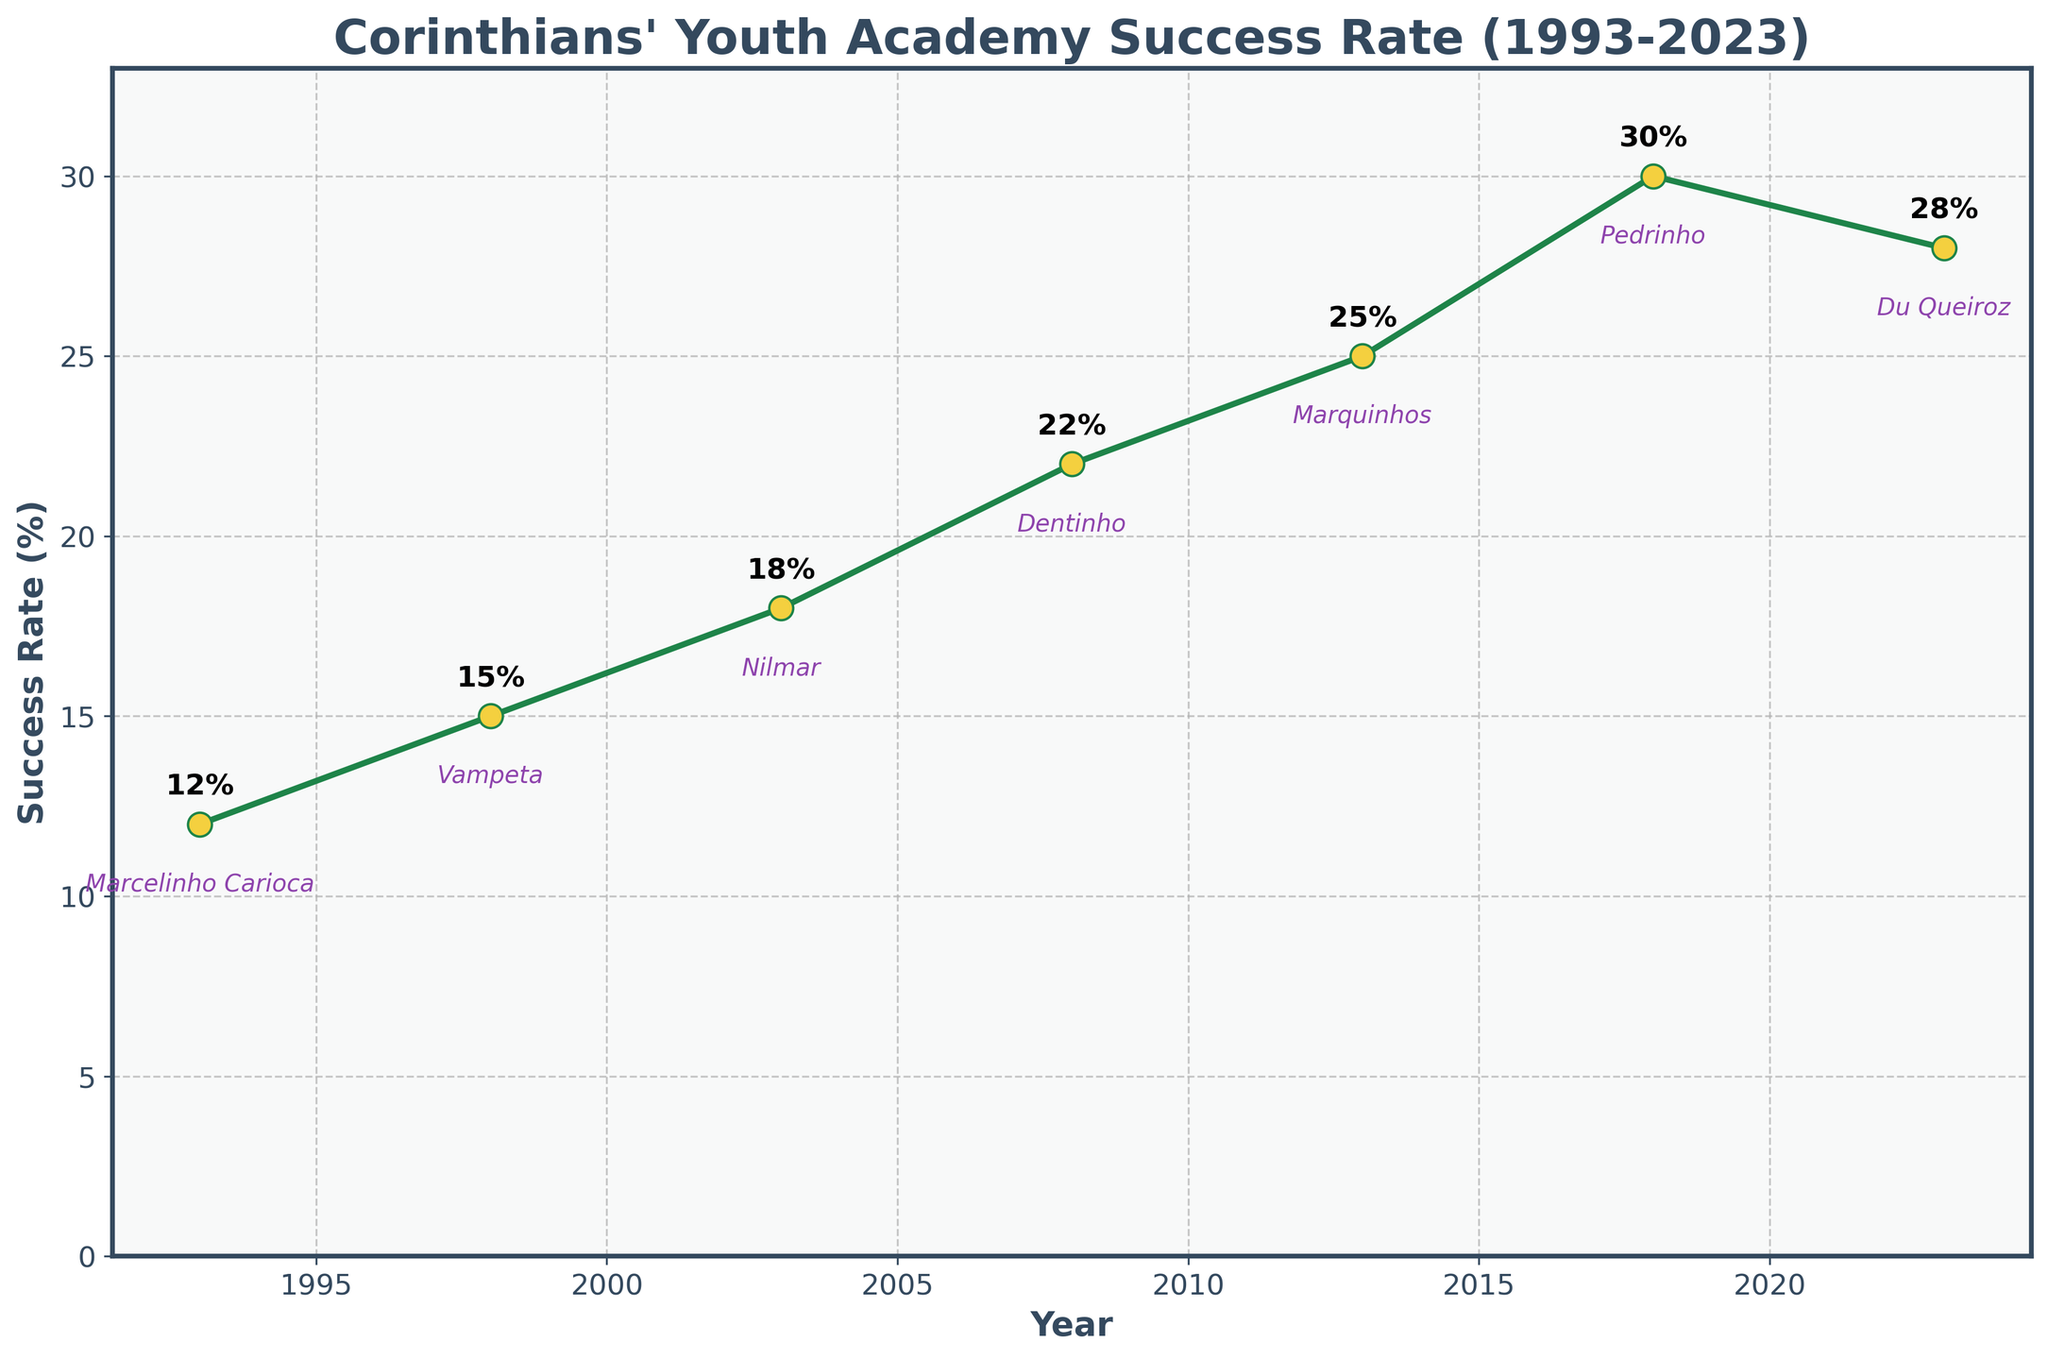What is the highest success rate recorded by Corinthians' youth academy in producing first-team players? The highest success rate can be observed visually from the chart. The peak value shown by the line is 30% which occurred in 2018.
Answer: 30% What trend can be observed in the success rate from 2013 to 2023? By looking at the line from 2013 to 2023, we can see a peak in 2018 followed by a slight decline. The success rate went from 25% in 2013, up to 30% in 2018, and slightly down to 28% in 2023.
Answer: Increasing then slightly decreasing Who is the notable player associated with the success rate of 15%? Locate the 15% success rate on the y-axis and follow the corresponding year marker on the x-axis. According to the annotation near the marker, the notable player for the year 1998, when the success rate was 15%, is Vampeta.
Answer: Vampeta How many years did the success rate remain under 20%? Sum the years where the success rate is below 20%: 1993 (12%), 1998 (15%), and 2003 (18%). So, there were three years under 20%.
Answer: 3 years What was the change in the success rate from 2008 to 2013? Identify success rates for both years (2008: 22%, 2013: 25%) and calculate the difference. (25% - 22%) = 3%.
Answer: 3% Compare the success rate in 1993 and 2023. What can you infer? The success rates for 1993 and 2023 are 12% and 28% respectively. This shows a significant increase (more than double) over the 30-year period.
Answer: Increased significantly In which year did the line show the most significant increase compared to the previous data point? Compare the increases between successive years by checking the vertical distances between neighboring points. The largest increase appears between 2008 (22%) and 2013 (25%), giving a rise of 3%.
Answer: 2013 Which two years have the closest success rates? Compare the success rates of all neighboring years. The closest values appear between 2018 (30%) and 2023 (28%) with a difference of just 2%.
Answer: 2018 and 2023 What is the notable player associated with the lowest success rate? Locate the lowest point on the y-axis, which is 12% in 1993. The annotation near the marker indicates that the notable player for this year is Marcelinho Carioca.
Answer: Marcelinho Carioca 